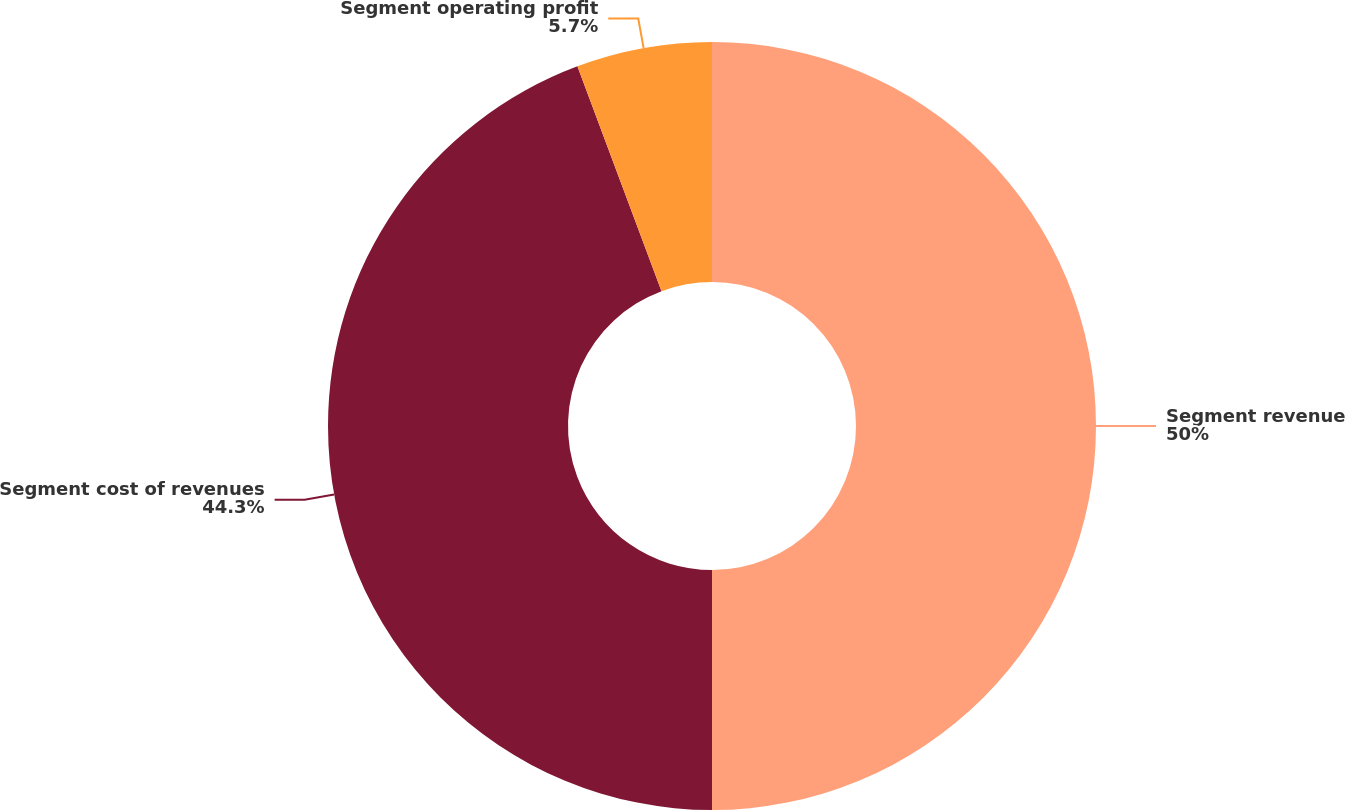Convert chart to OTSL. <chart><loc_0><loc_0><loc_500><loc_500><pie_chart><fcel>Segment revenue<fcel>Segment cost of revenues<fcel>Segment operating profit<nl><fcel>50.0%<fcel>44.3%<fcel>5.7%<nl></chart> 